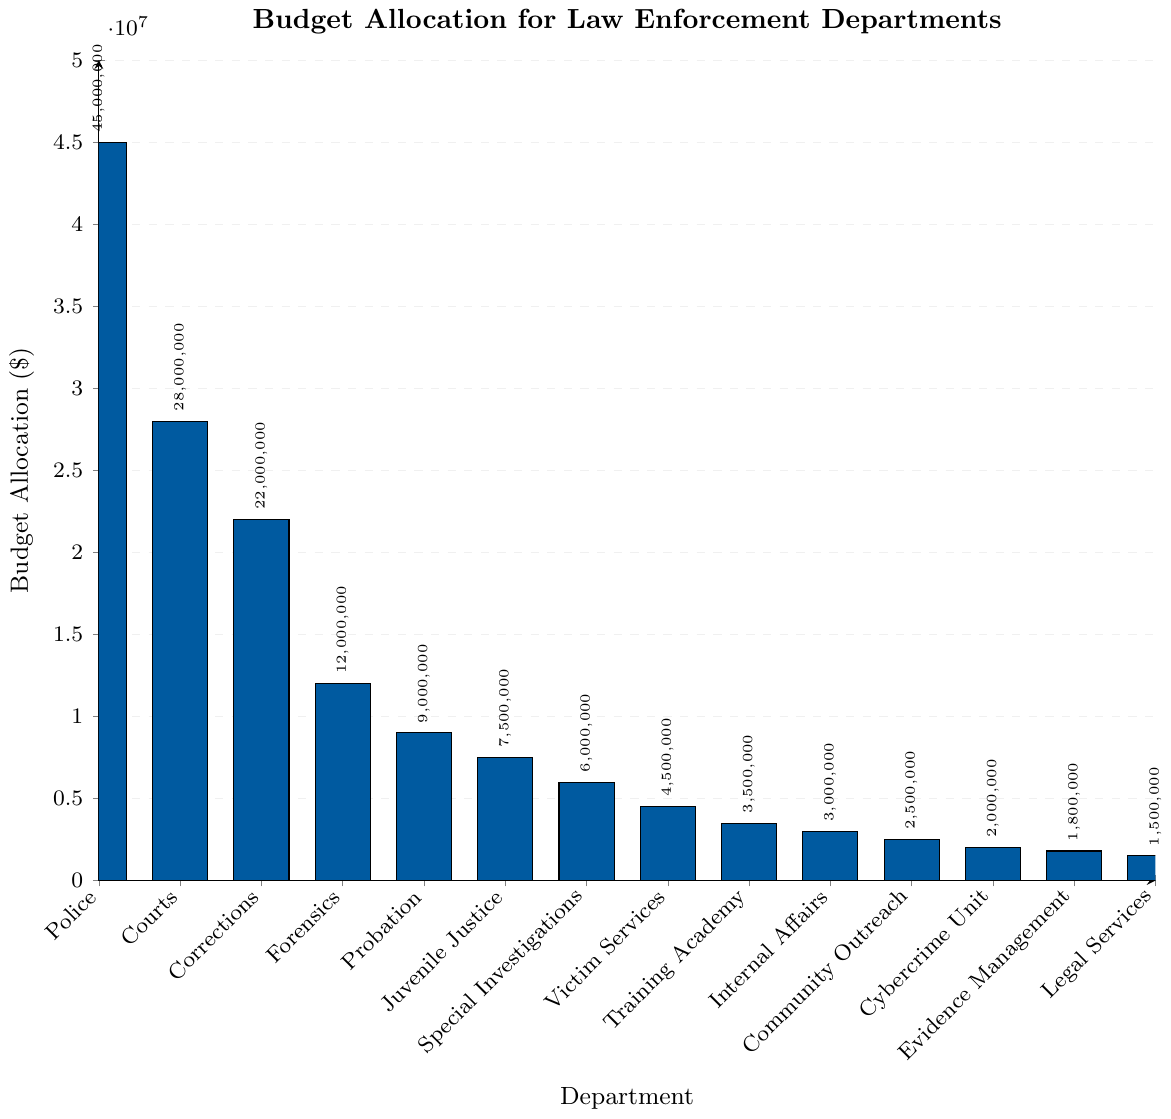What's the total budget allocation for Forensics, Probation, and Juvenile Justice combined? First, identify the budget allocation for Forensics ($12,000,000), Probation ($9,000,000), and Juvenile Justice ($7,500,000). Add these amounts together: $12,000,000 + $9,000,000 + $7,500,000 = $28,500,000.
Answer: $28,500,000 Which department receives the highest budget allocation? Identify the department with the tallest bar in the bar chart. The Police department has the highest budget allocation at $45,000,000.
Answer: Police How much more budget does the Police department receive compared to the Courts? Determine the budget for both the Police ($45,000,000) and the Courts ($28,000,000). Subtract the Courts' budget from the Police's budget: $45,000,000 - $28,000,000 = $17,000,000.
Answer: $17,000,000 List the departments with a budget allocation less than $5,000,000. Identify each department with a bar height under $5,000,000. These include Victim Services ($4,500,000), Training Academy ($3,500,000), Internal Affairs ($3,000,000), Community Outreach ($2,500,000), Cybercrime Unit ($2,000,000), Evidence Management ($1,800,000), and Legal Services ($1,500,000).
Answer: Victim Services, Training Academy, Internal Affairs, Community Outreach, Cybercrime Unit, Evidence Management, Legal Services What's the average budget allocation for all departments? Add the budget allocations for all departments: $45,000,000 + $28,000,000 + $22,000,000 + $12,000,000 + $9,000,000 + $7,500,000 + $6,000,000 + $4,500,000 + $3,500,000 + $3,000,000 + $2,500,000 + $2,000,000 + $1,800,000 + $1,500,000 = $148,300,000. Divide this sum by the number of departments (14): $148,300,000 / 14 ≈ $10,592,857.
Answer: $10,592,857 Which two departments have the closest budget allocations, and what is the difference between their budgets? Identify departments with similar bar heights. The Cybercrime Unit and Evidence Management have the closest budgets, $2,000,000 and $1,800,000 respectively. Calculate the difference: $2,000,000 - $1,800,000 = $200,000.
Answer: Cybercrime Unit and Evidence Management, $200,000 What percentage of the total budget is allocated to the Police department? First, find the total budget by summing all allocations: $148,300,000. Then, calculate the percentage for the Police: ($45,000,000 / $148,300,000) * 100 ≈ 30.34%.
Answer: ≈ 30.34% Is there a department whose budget allocation is exactly half of another department's? If so, name them. Compare the budget allocations for possible halvings. The Forensics department receives $12,000,000 and the Juvenile Justice department receives $7,500,000. Half of the Forensics budget is $6,000,000 which matches the Special Investigations budget. Confirm this: $12,000,000 / 2 = $6,000,000.
Answer: Forensics and Special Investigations 